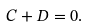Convert formula to latex. <formula><loc_0><loc_0><loc_500><loc_500>C + D = 0 .</formula> 